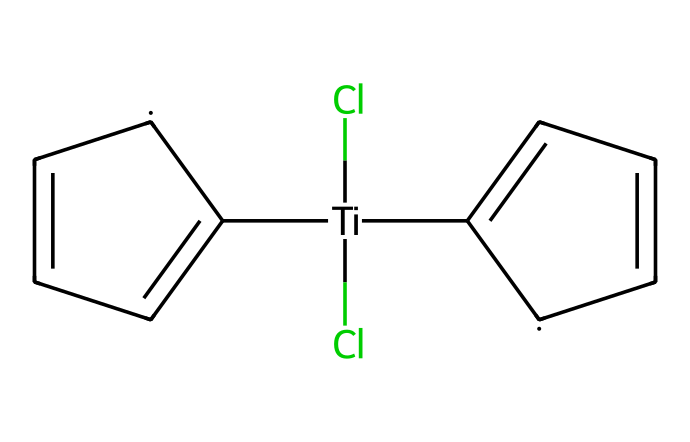What is the central metal atom in titanocene dichloride? The chemical structure indicates that the central metal atom is titanium, which is denoted by the notation [Ti].
Answer: titanium How many chlorine atoms are present in titanocene dichloride? The structure shows two chlorine atoms attached to the titanium atom, indicated by (Cl)(Cl) in the SMILES representation.
Answer: 2 What type of chemical compound is titanocene dichloride? Titanocene dichloride is classified as a metallocene due to its metal center (titanium) sandwiched between cyclopentadienyl anions.
Answer: metallocene How many cyclopentadienyl rings are present in titanocene dichloride? From the structure, there are two cyclopentadienyl rings as represented by the two C1=CC=C[CH]1 segments in the SMILES notation.
Answer: 2 Why is titanocene dichloride considered an organometallic compound? Titanocene dichloride is considered organometallic because it contains a metal (titanium) directly bonded to carbon atoms from the cyclopentadienyl rings, which qualifies as an organometallic structure.
Answer: organometallic What geometrical arrangement is expected for titanocene dichloride based on its structure? The expected geometry for titanocene dichloride is typically a piano stool arrangement due to its metallocene nature, with the metal in the center and two cyclopentadienyl rings above and below.
Answer: piano stool What is the potential application of titanocene dichloride in organic synthesis? Titanocene dichloride can be used as a catalyst in organic synthesis, facilitating various chemical reactions due to its unique properties.
Answer: catalyst 